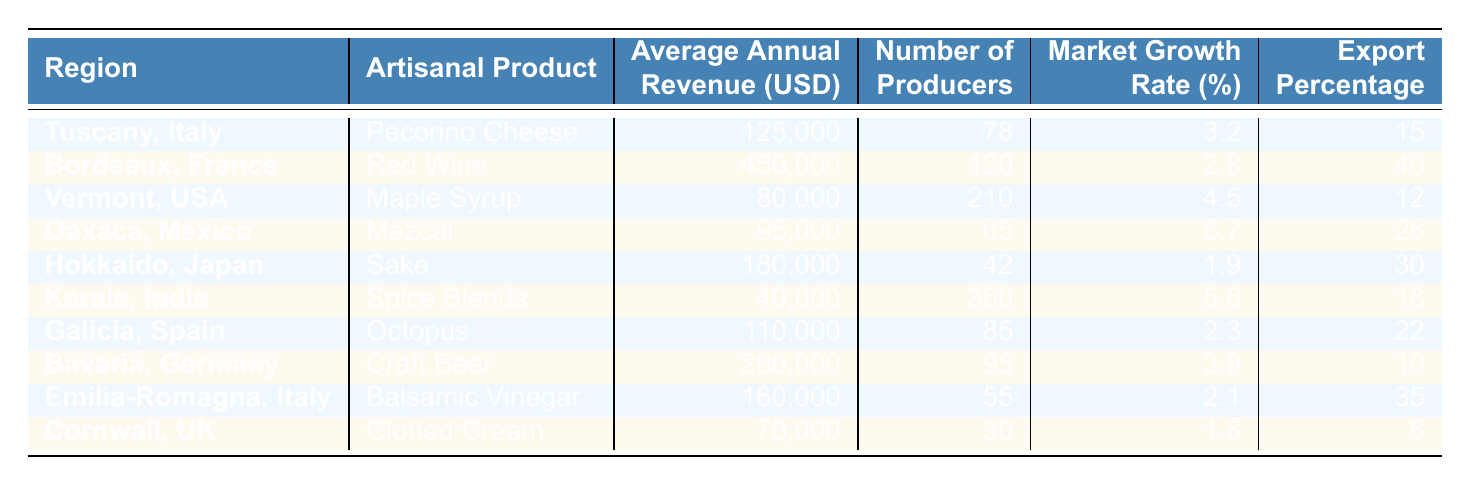What is the average annual revenue of artisanal food producers in Bordeaux, France? The table shows that the average annual revenue for artisanal food producers in Bordeaux, France is listed as 450,000 USD.
Answer: 450000 Which region has the highest average annual revenue for its artisanal product? By examining the "Average Annual Revenue (USD)" column, Bordeaux, France has the highest average annual revenue at 450,000 USD.
Answer: Bordeaux, France Calculate the total number of producers for all regions listed in the table. Adding the number of producers from each region: 78 + 120 + 210 + 65 + 42 + 350 + 85 + 95 + 55 + 30 = 1,030.
Answer: 1030 Is the market growth rate of mezcal in Oaxaca, Mexico higher than that of Sake in Hokkaido, Japan? Mezcal in Oaxaca has a market growth rate of 6.7%, while Sake in Hokkaido has a growth rate of 1.9%. Since 6.7% is greater than 1.9%, the statement is true.
Answer: Yes What is the average market growth rate of artisanal food products across all the regions listed? The average market growth rate can be calculated by summing all the growth rates: (3.2 + 2.8 + 4.5 + 6.7 + 1.9 + 5.6 + 2.3 + 3.9 + 2.1 + 1.5) = 32.5%, and dividing by the number of regions (10) gives 32.5 / 10 = 3.25%.
Answer: 3.25% Which region has the lowest export percentage for its artisanal product? Looking through the "Export Percentage" column, Cornwall, UK has the lowest export percentage listed at 5%.
Answer: Cornwall, UK What is the difference in average annual revenue between the region with the highest and lowest revenues? The highest revenue is from Bordeaux at 450,000 USD, and the lowest from Kerala at 40,000 USD. The difference is 450,000 - 40,000 = 410,000 USD.
Answer: 410000 Do all regions have an export percentage greater than 10%? By examining the "Export Percentage" column, we see that Kerala, India (18%) and Cornwall, UK (5%) both have percentages less than 10%. Thus, the statement is false.
Answer: No Which artisanal products have an average annual revenue above 100,000 USD? The products that have revenues above 100,000 USD are Red Wine (450,000), Craft Beer (200,000), Balsamic Vinegar (160,000), and Sake (180,000).
Answer: Red Wine, Craft Beer, Balsamic Vinegar, Sake What region has the highest number of producers, and how many are there? The region with the highest number of producers is Kerala, India, which has 350 producers listed.
Answer: Kerala, India, 350 